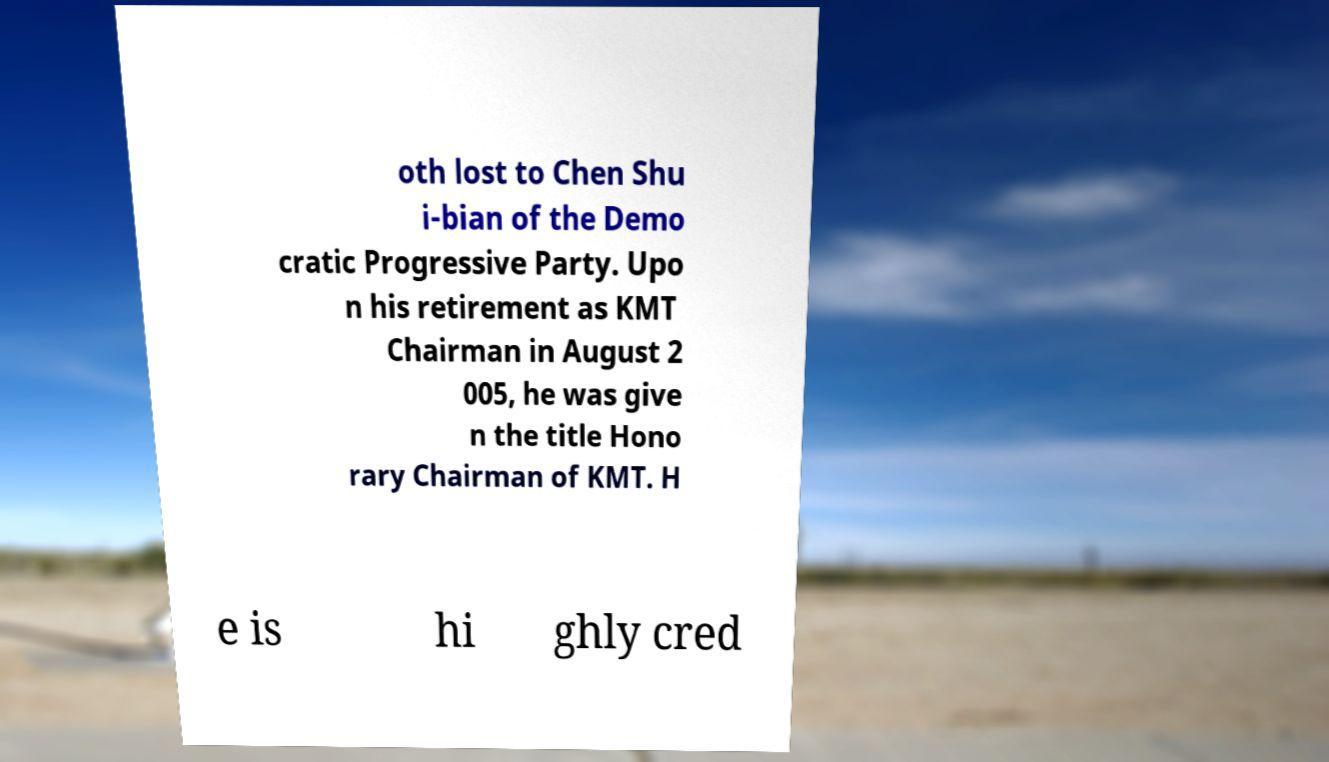Could you extract and type out the text from this image? oth lost to Chen Shu i-bian of the Demo cratic Progressive Party. Upo n his retirement as KMT Chairman in August 2 005, he was give n the title Hono rary Chairman of KMT. H e is hi ghly cred 